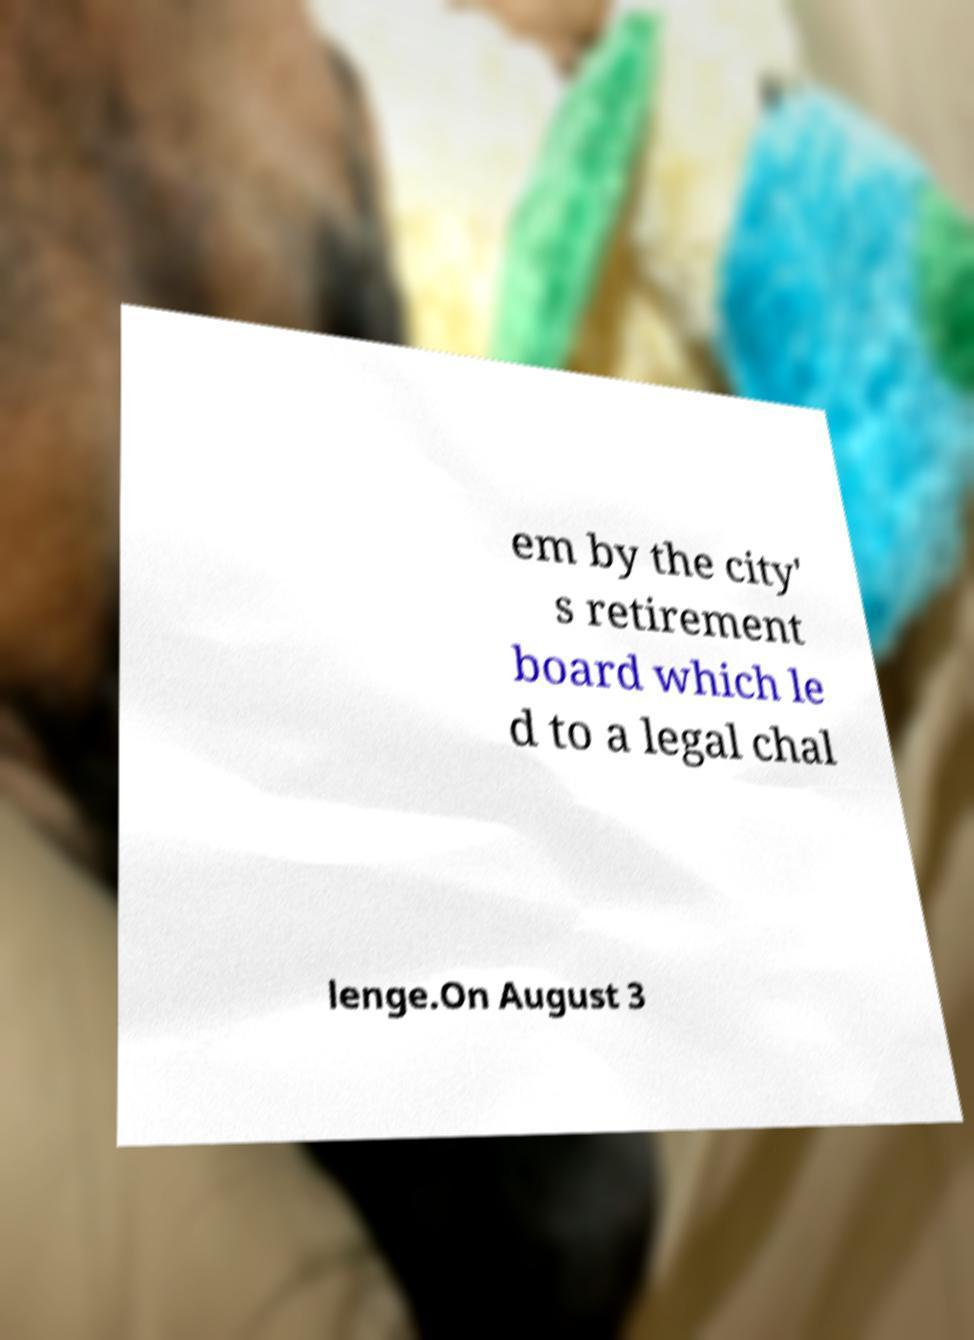Could you assist in decoding the text presented in this image and type it out clearly? em by the city' s retirement board which le d to a legal chal lenge.On August 3 